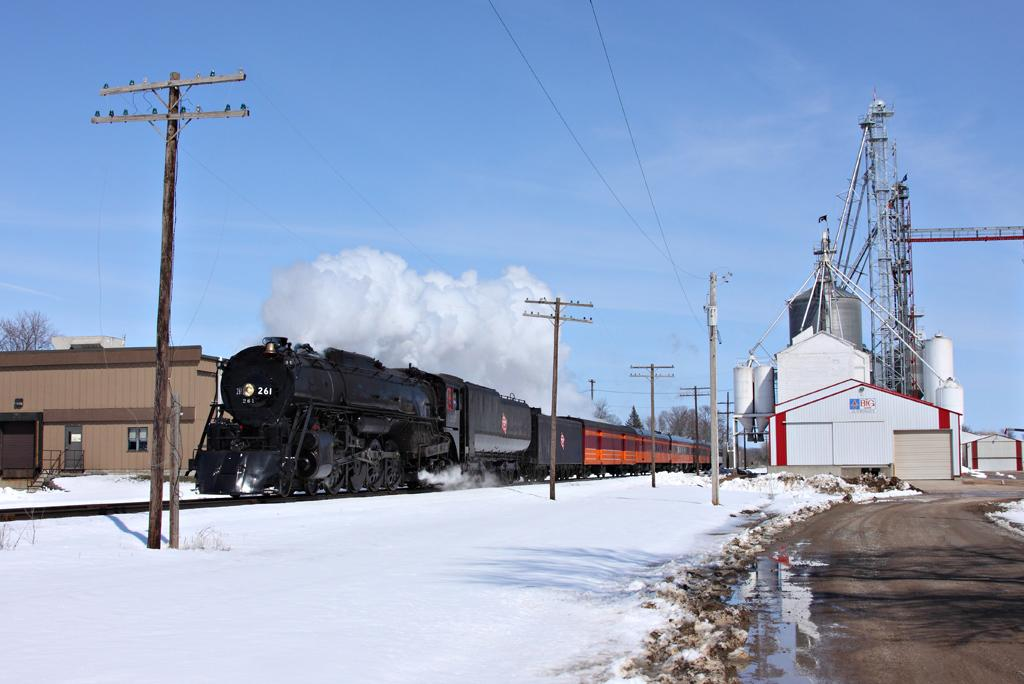What type of structure is in the image? There is a railway station in the image. What is the condition of the ground in the image? The ground has a snow surface. What can be seen attached to the poles in the image? There are poles with wires in the image. What is located beside the railway station? A train is present beside the railway station. What is visible in the background of the image? The sky is visible in the background of the image. What type of weather can be inferred from the image? Clouds are present in the sky, suggesting that it might be overcast or snowy. Where is the harbor located in the image? There is no harbor present in the image. What type of truck can be seen delivering goods to the railway station? There is no truck visible in the image. 